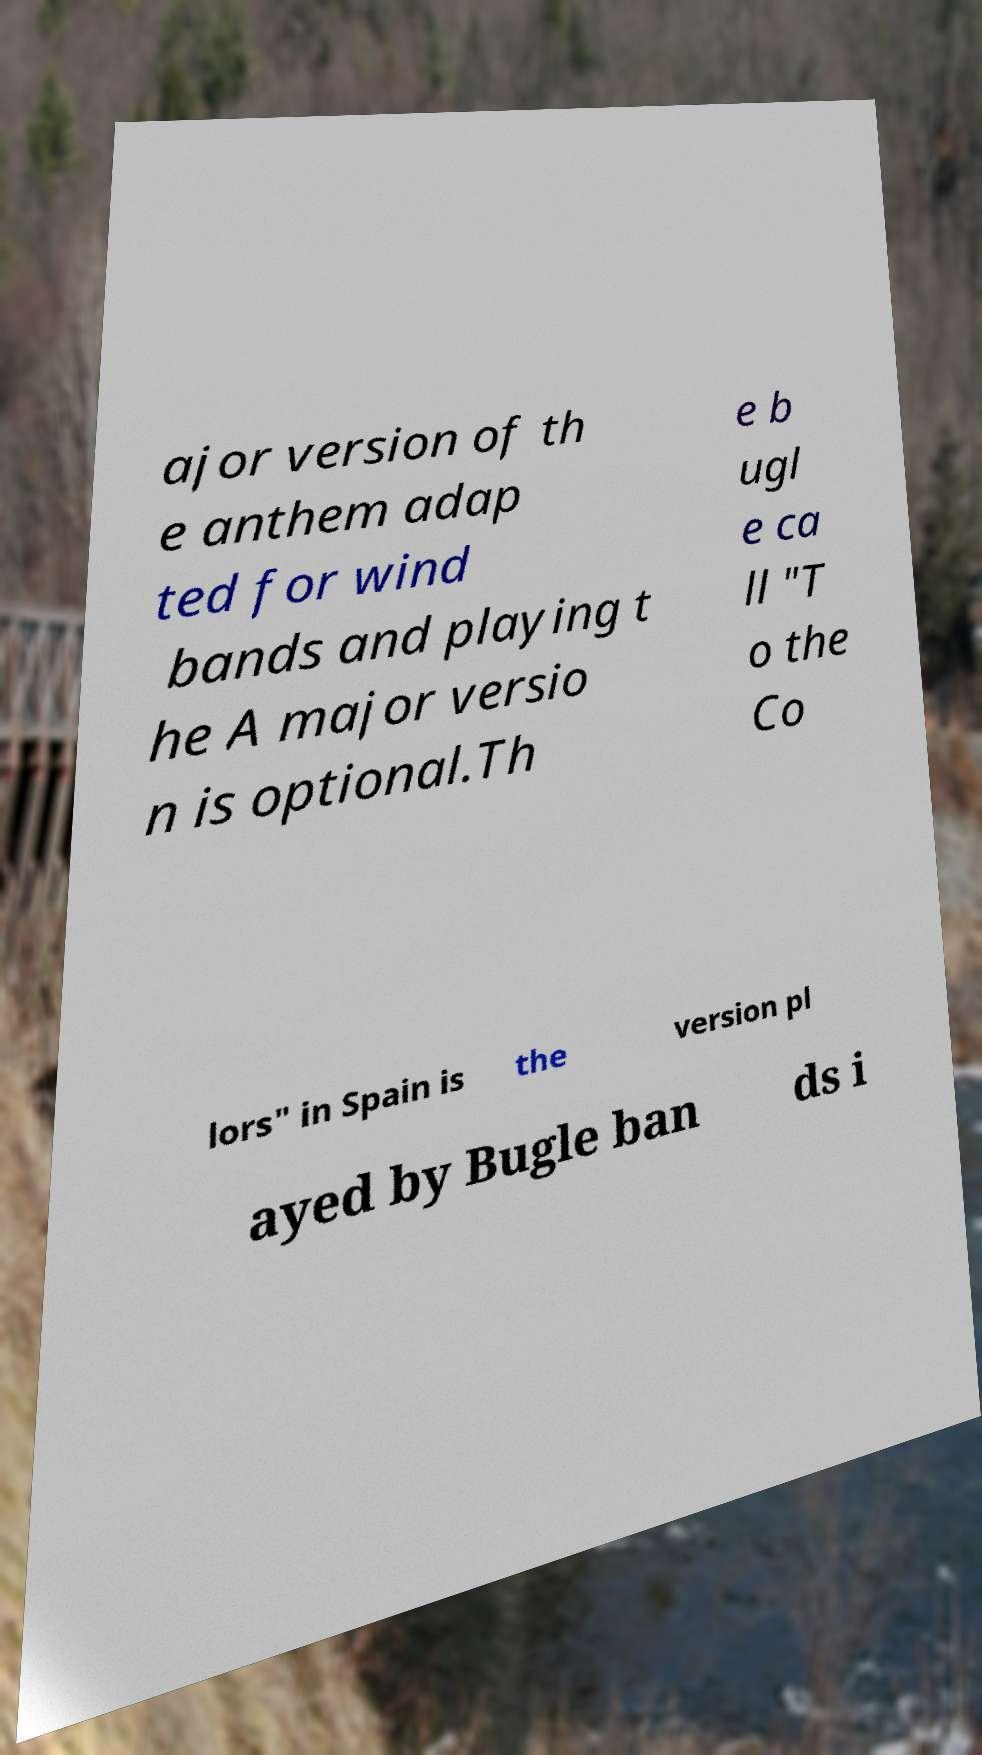I need the written content from this picture converted into text. Can you do that? ajor version of th e anthem adap ted for wind bands and playing t he A major versio n is optional.Th e b ugl e ca ll "T o the Co lors" in Spain is the version pl ayed by Bugle ban ds i 